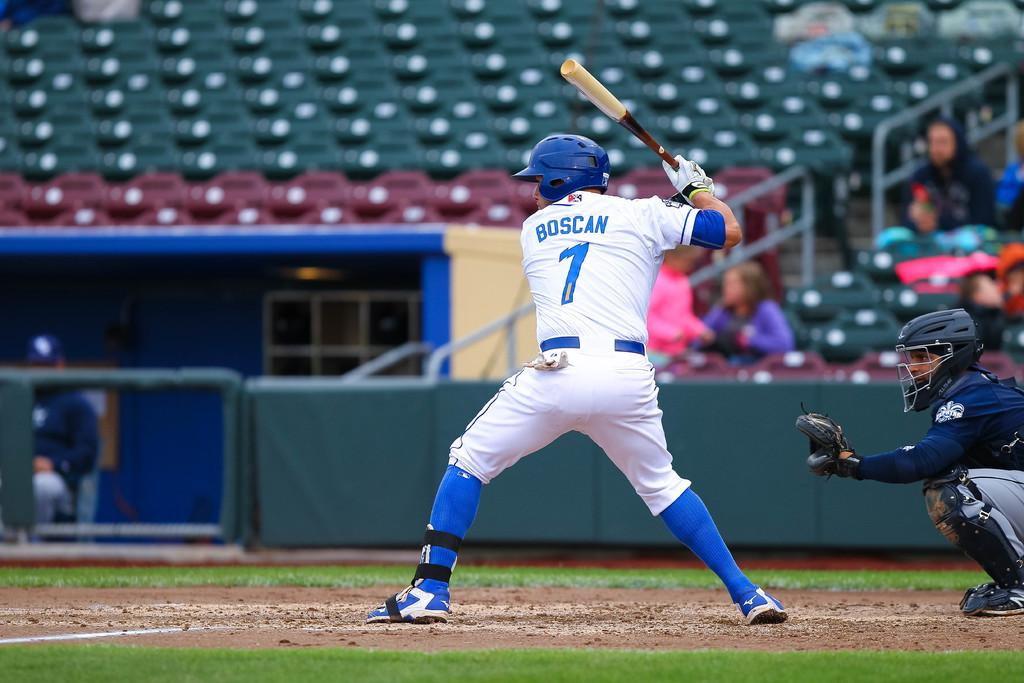<image>
Render a clear and concise summary of the photo. Boscan is up to bat and ready to swing 